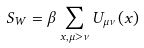<formula> <loc_0><loc_0><loc_500><loc_500>S _ { W } = \beta \sum _ { x , \mu > \nu } U _ { \mu \nu } ( x )</formula> 